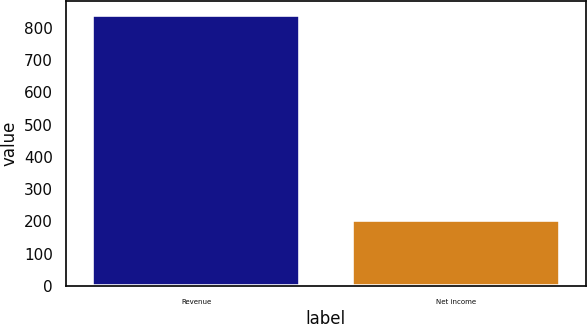Convert chart. <chart><loc_0><loc_0><loc_500><loc_500><bar_chart><fcel>Revenue<fcel>Net income<nl><fcel>840.9<fcel>205.6<nl></chart> 